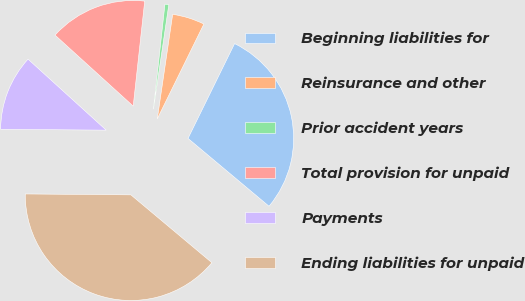Convert chart to OTSL. <chart><loc_0><loc_0><loc_500><loc_500><pie_chart><fcel>Beginning liabilities for<fcel>Reinsurance and other<fcel>Prior accident years<fcel>Total provision for unpaid<fcel>Payments<fcel>Ending liabilities for unpaid<nl><fcel>28.83%<fcel>4.94%<fcel>0.59%<fcel>15.0%<fcel>11.6%<fcel>39.04%<nl></chart> 